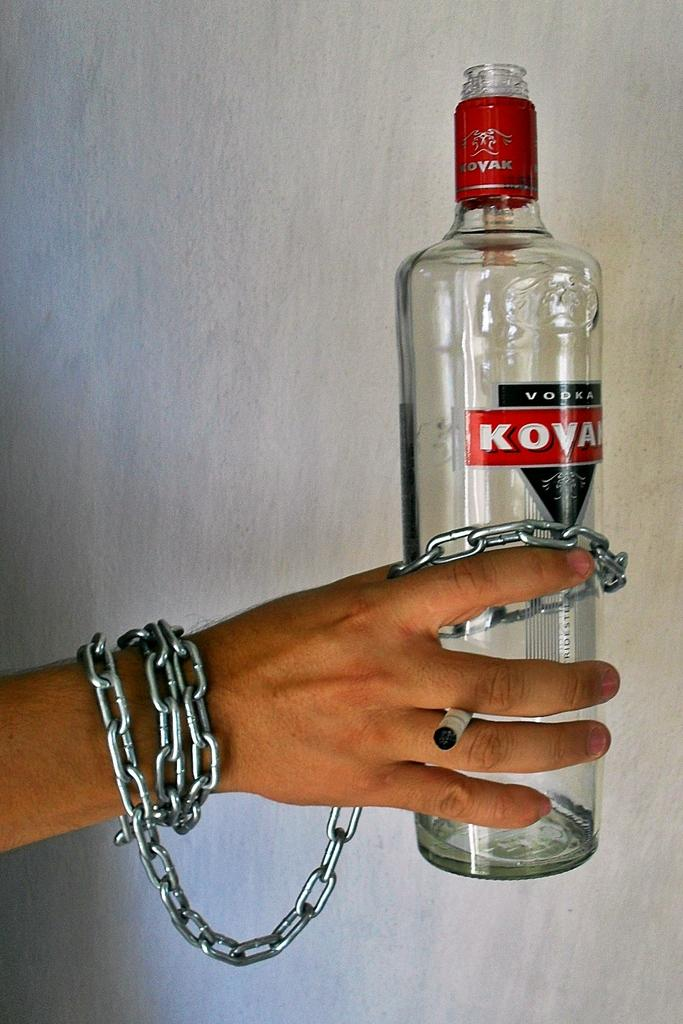<image>
Render a clear and concise summary of the photo. the word kovak is on a wine bottle 